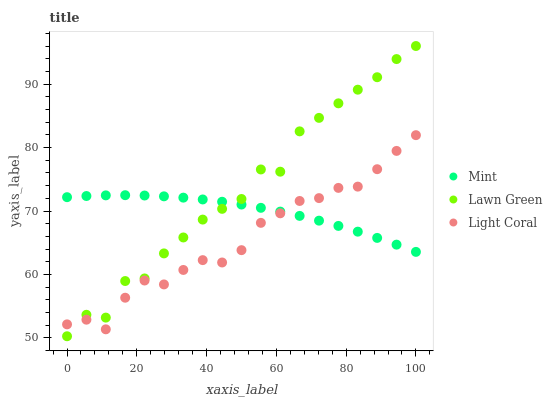Does Light Coral have the minimum area under the curve?
Answer yes or no. Yes. Does Lawn Green have the maximum area under the curve?
Answer yes or no. Yes. Does Mint have the minimum area under the curve?
Answer yes or no. No. Does Mint have the maximum area under the curve?
Answer yes or no. No. Is Mint the smoothest?
Answer yes or no. Yes. Is Lawn Green the roughest?
Answer yes or no. Yes. Is Lawn Green the smoothest?
Answer yes or no. No. Is Mint the roughest?
Answer yes or no. No. Does Lawn Green have the lowest value?
Answer yes or no. Yes. Does Mint have the lowest value?
Answer yes or no. No. Does Lawn Green have the highest value?
Answer yes or no. Yes. Does Mint have the highest value?
Answer yes or no. No. Does Lawn Green intersect Mint?
Answer yes or no. Yes. Is Lawn Green less than Mint?
Answer yes or no. No. Is Lawn Green greater than Mint?
Answer yes or no. No. 